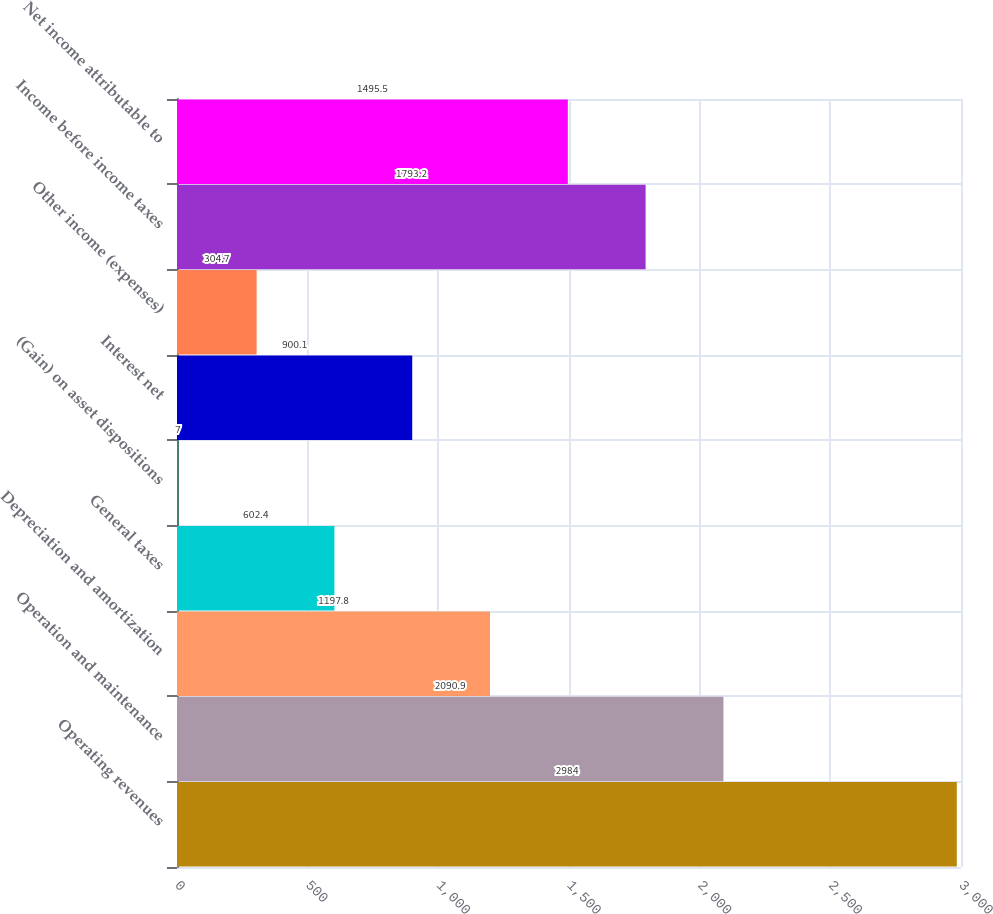Convert chart to OTSL. <chart><loc_0><loc_0><loc_500><loc_500><bar_chart><fcel>Operating revenues<fcel>Operation and maintenance<fcel>Depreciation and amortization<fcel>General taxes<fcel>(Gain) on asset dispositions<fcel>Interest net<fcel>Other income (expenses)<fcel>Income before income taxes<fcel>Net income attributable to<nl><fcel>2984<fcel>2090.9<fcel>1197.8<fcel>602.4<fcel>7<fcel>900.1<fcel>304.7<fcel>1793.2<fcel>1495.5<nl></chart> 